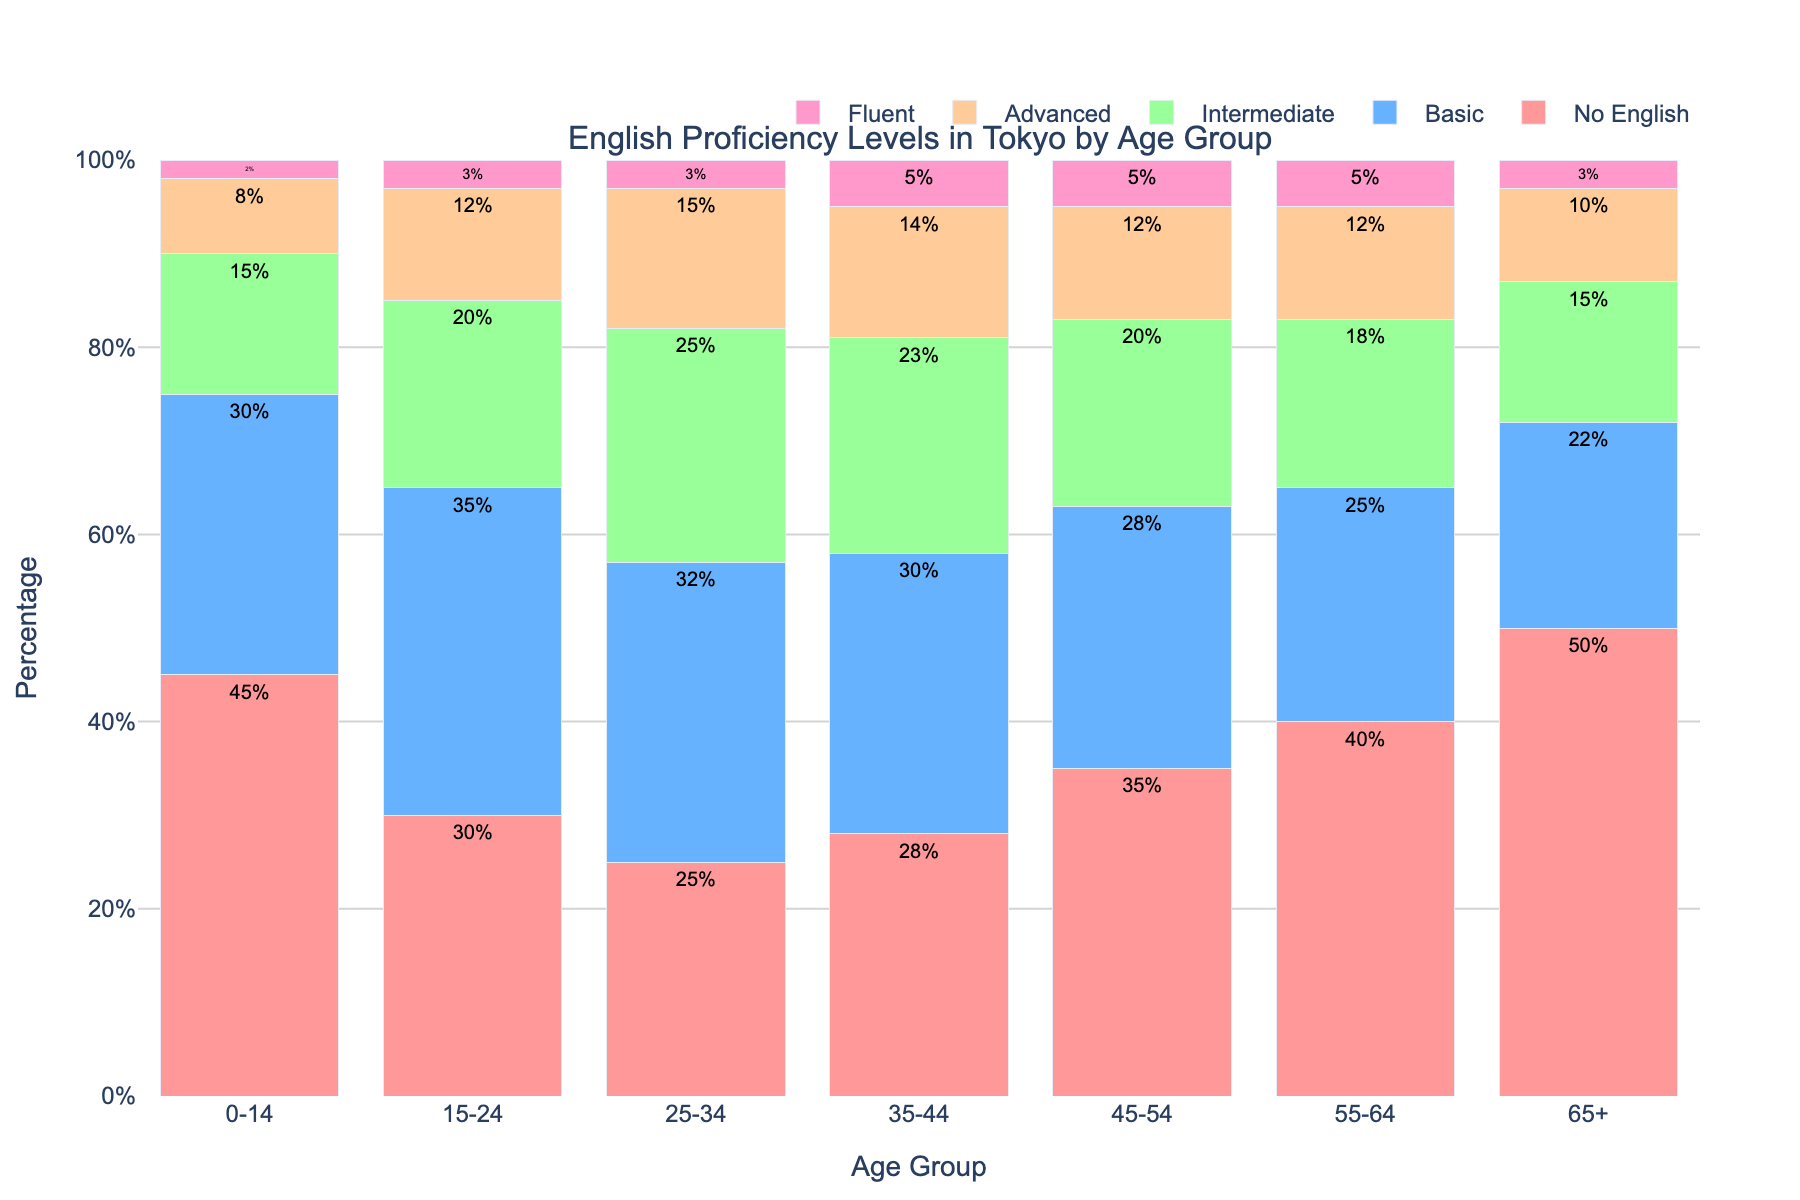Which age group has the highest percentage of residents with no English proficiency? By examining the bars representing the "No English" category, the bar corresponding to the "65+" age group is the tallest. Hence, this group has the highest percentage.
Answer: 65+ Which age group has the highest percentage of residents who are fluent in English? By looking at the bars under the "Fluent" category, the "35-44" and "45-54" age groups have the tallest bars, each representing 5%.
Answer: 35-44 and 45-54 What is the combined percentage of residents aged 25-34 with intermediate and advanced English proficiency? The "Intermediate" percentage for the 25-34 age group is 25%, and the "Advanced" percentage is 15%. Adding these together gives 25% + 15% = 40%.
Answer: 40% Which age group has a higher percentage of basic English proficiency, 15-24 or 45-54? By comparing the bars for the "Basic" category, the "15-24" group shows a bar height of 35%, whereas the "45-54" group shows 28%. Therefore, the "15-24" age group has a higher percentage.
Answer: 15-24 What is the difference in the percentage of fluent English speakers between the age groups 0-14 and 15-24? The "Fluent" percentage for the 0-14 age group is 2%, and for the 15-24 age group, it is 3%. The difference is 3% - 2% = 1%.
Answer: 1% Which age group has the lowest percentage of advanced English proficiency? By examining the bars under the "Advanced" category, the 0-14 age group has the shortest bar at 8%.
Answer: 0-14 For the 55-64 age group, how many categories exceed 15% in terms of English proficiency? In the 55-64 age group, the "No English" category is 40%, and the "Basic" category is 25%, both of which exceed 15%. Only these two categories exceed 15%.
Answer: 2 